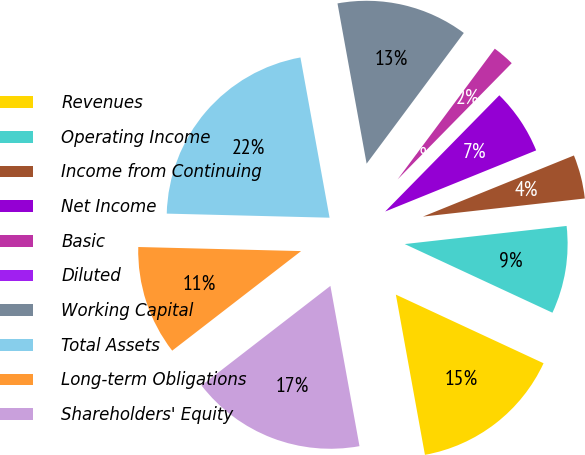Convert chart to OTSL. <chart><loc_0><loc_0><loc_500><loc_500><pie_chart><fcel>Revenues<fcel>Operating Income<fcel>Income from Continuing<fcel>Net Income<fcel>Basic<fcel>Diluted<fcel>Working Capital<fcel>Total Assets<fcel>Long-term Obligations<fcel>Shareholders' Equity<nl><fcel>15.22%<fcel>8.7%<fcel>4.35%<fcel>6.52%<fcel>2.18%<fcel>0.0%<fcel>13.04%<fcel>21.74%<fcel>10.87%<fcel>17.39%<nl></chart> 